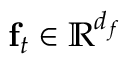Convert formula to latex. <formula><loc_0><loc_0><loc_500><loc_500>f _ { t } \in \mathbb { R } ^ { d _ { f } }</formula> 